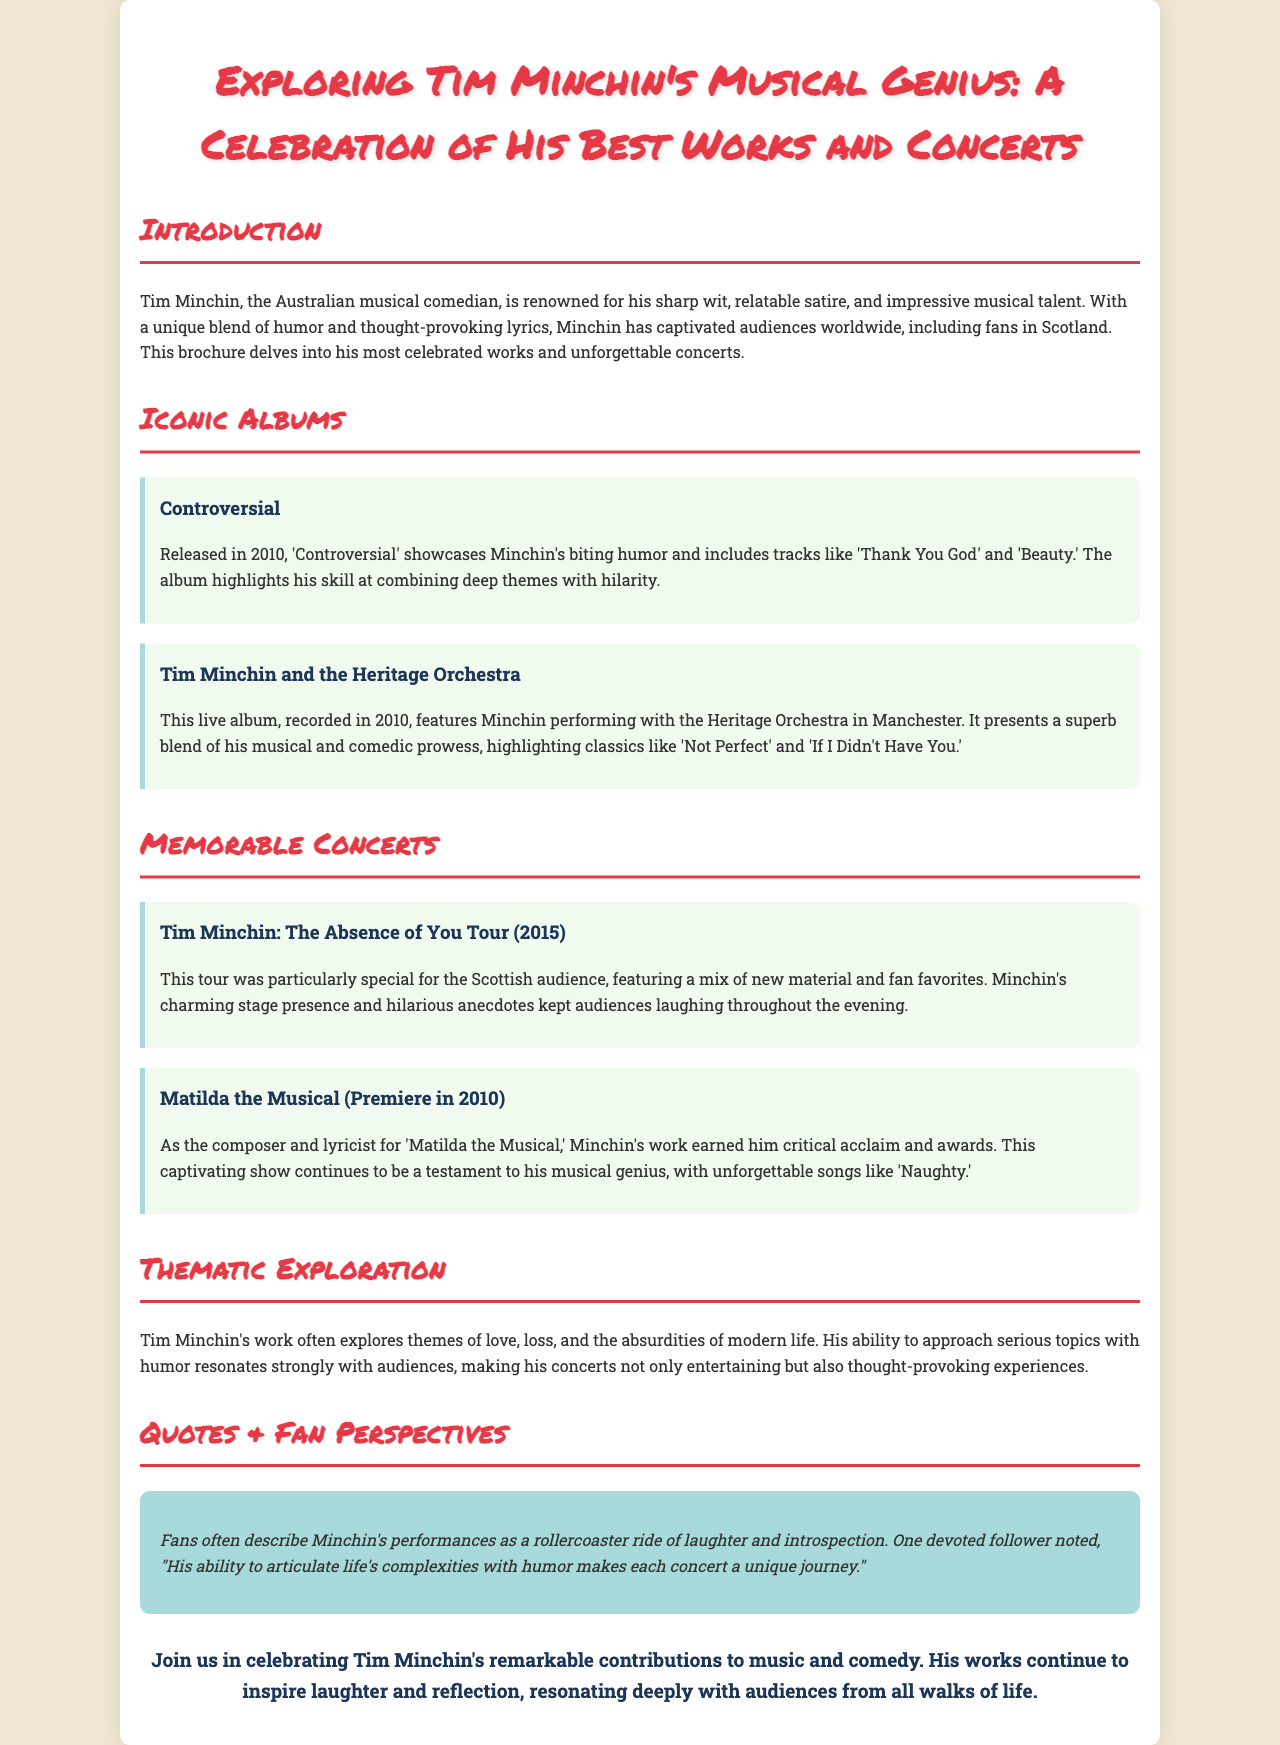What is the title of the brochure? The title of the brochure is presented prominently at the top, emphasizing the focus on Tim Minchin's work and concerts.
Answer: Exploring Tim Minchin's Musical Genius: A Celebration of His Best Works and Concerts What is one album released in 2010? The brochure specifically highlights several albums, including one that was released in 2010.
Answer: Controversial What is the name of the live album recorded in 2010? The document mentions a live album recorded with the Heritage Orchestra in Manchester in 2010.
Answer: Tim Minchin and the Heritage Orchestra What year did the "Absence of You Tour" take place? The details in the brochure specify the year of the concert tour to be particularly significant.
Answer: 2015 What song is highlighted from "Matilda the Musical"? The brochure states a memorable song from the musical composed by Tim Minchin.
Answer: Naughty What themes does Tim Minchin often explore in his work? The document lists specific themes that are recurrent in Tim Minchin's performances.
Answer: Love, loss, and the absurdities of modern life How do fans often describe Minchin's performances? The brochure captures fan sentiments about the nature of Minchin's performances.
Answer: A rollercoaster ride of laughter and introspection What type of comedy is Tim Minchin known for? The introduction section discusses the unique blend characteristic of Tim Minchin's art.
Answer: Musical comedy 